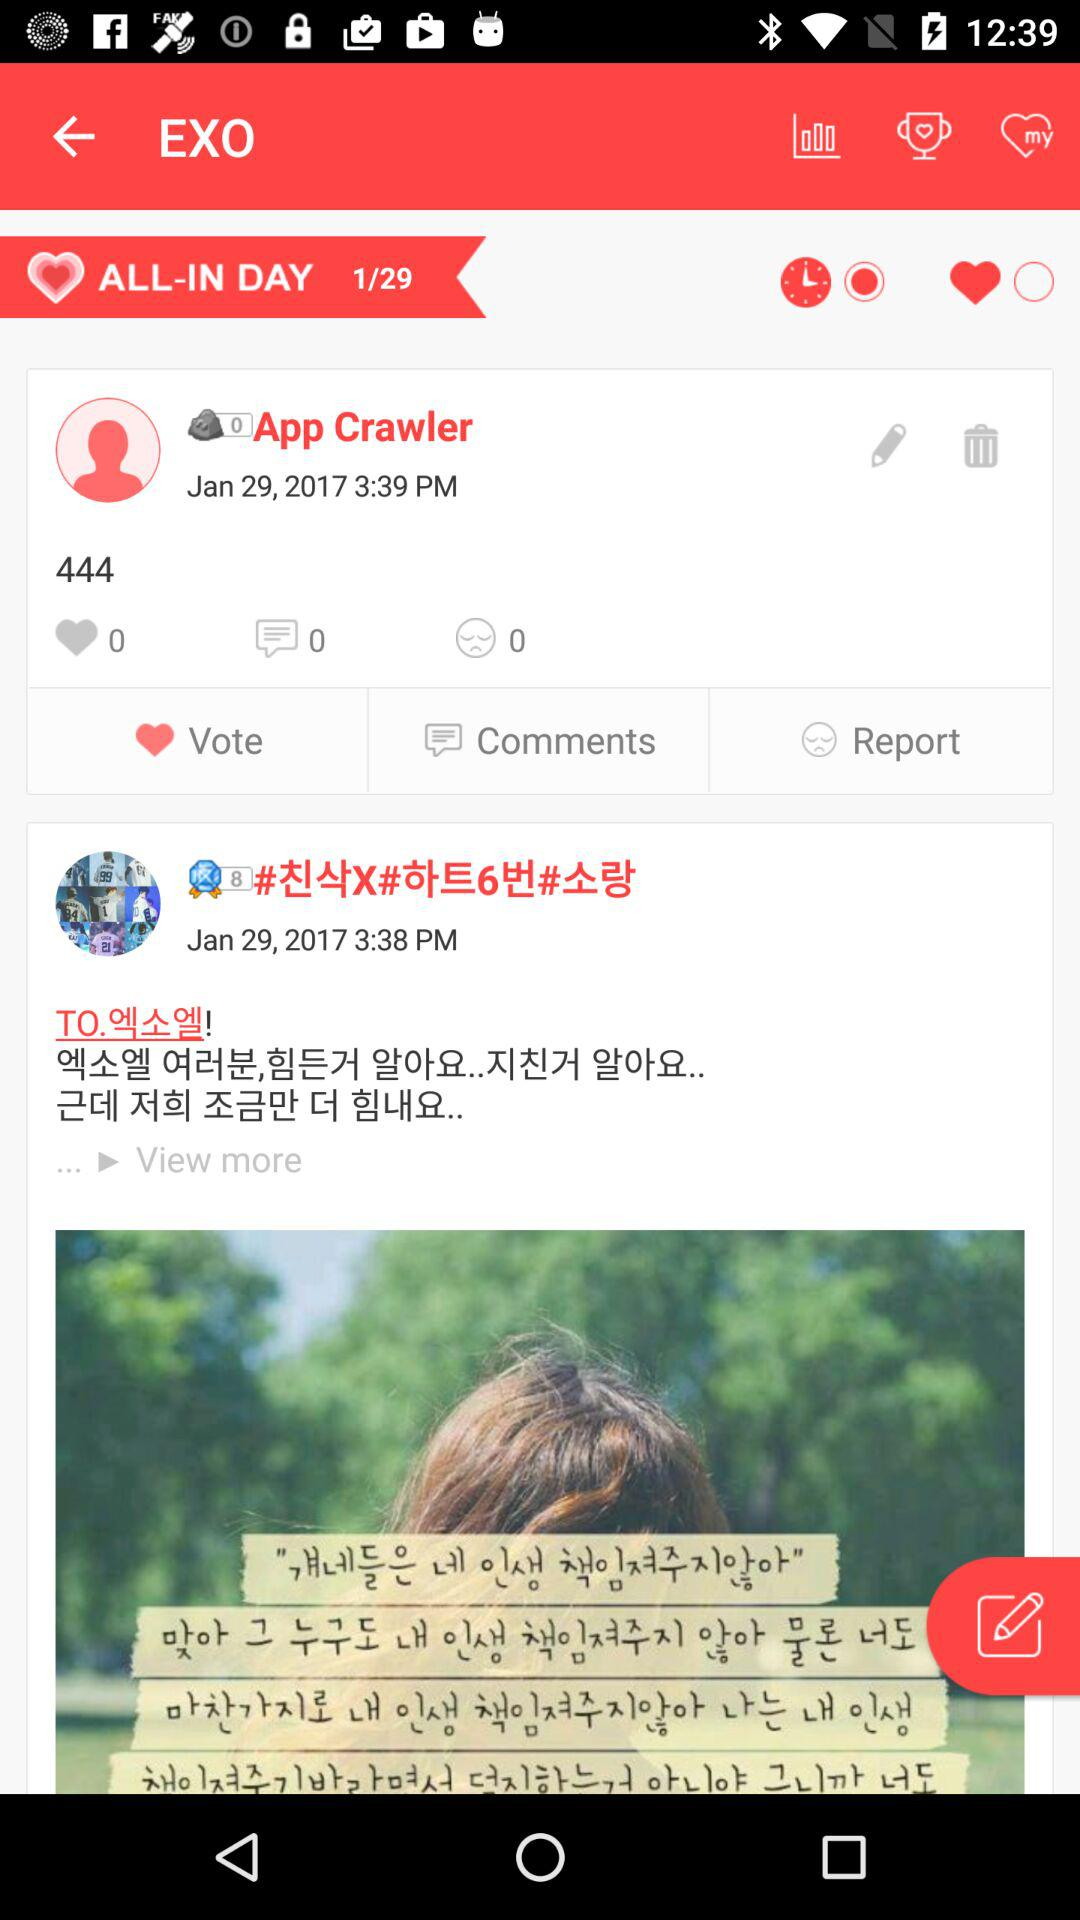What is the date on which App Crawler uploaded the post? The date is January 29, 2017. 